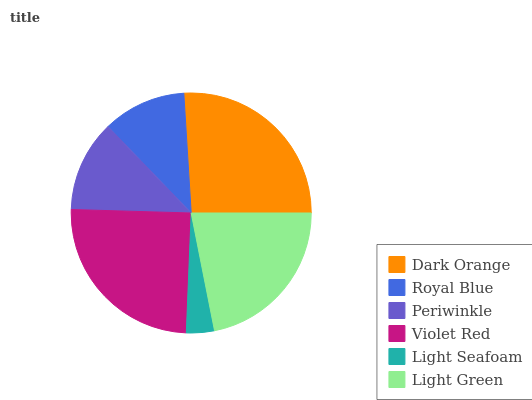Is Light Seafoam the minimum?
Answer yes or no. Yes. Is Dark Orange the maximum?
Answer yes or no. Yes. Is Royal Blue the minimum?
Answer yes or no. No. Is Royal Blue the maximum?
Answer yes or no. No. Is Dark Orange greater than Royal Blue?
Answer yes or no. Yes. Is Royal Blue less than Dark Orange?
Answer yes or no. Yes. Is Royal Blue greater than Dark Orange?
Answer yes or no. No. Is Dark Orange less than Royal Blue?
Answer yes or no. No. Is Light Green the high median?
Answer yes or no. Yes. Is Periwinkle the low median?
Answer yes or no. Yes. Is Violet Red the high median?
Answer yes or no. No. Is Royal Blue the low median?
Answer yes or no. No. 